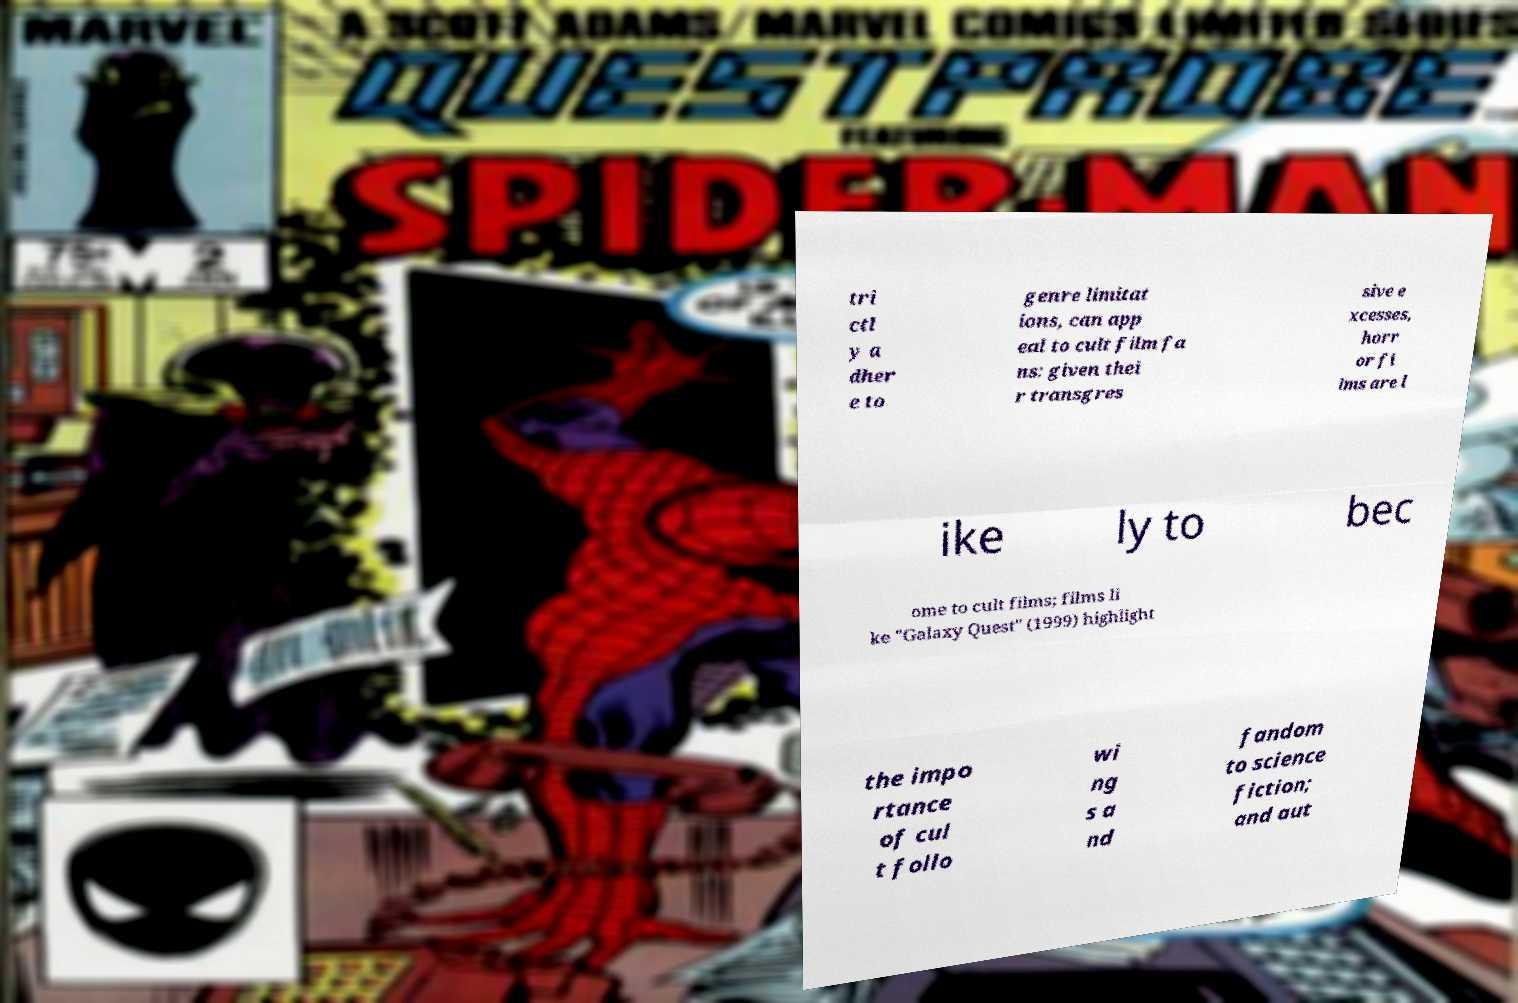I need the written content from this picture converted into text. Can you do that? tri ctl y a dher e to genre limitat ions, can app eal to cult film fa ns: given thei r transgres sive e xcesses, horr or fi lms are l ike ly to bec ome to cult films; films li ke "Galaxy Quest" (1999) highlight the impo rtance of cul t follo wi ng s a nd fandom to science fiction; and aut 